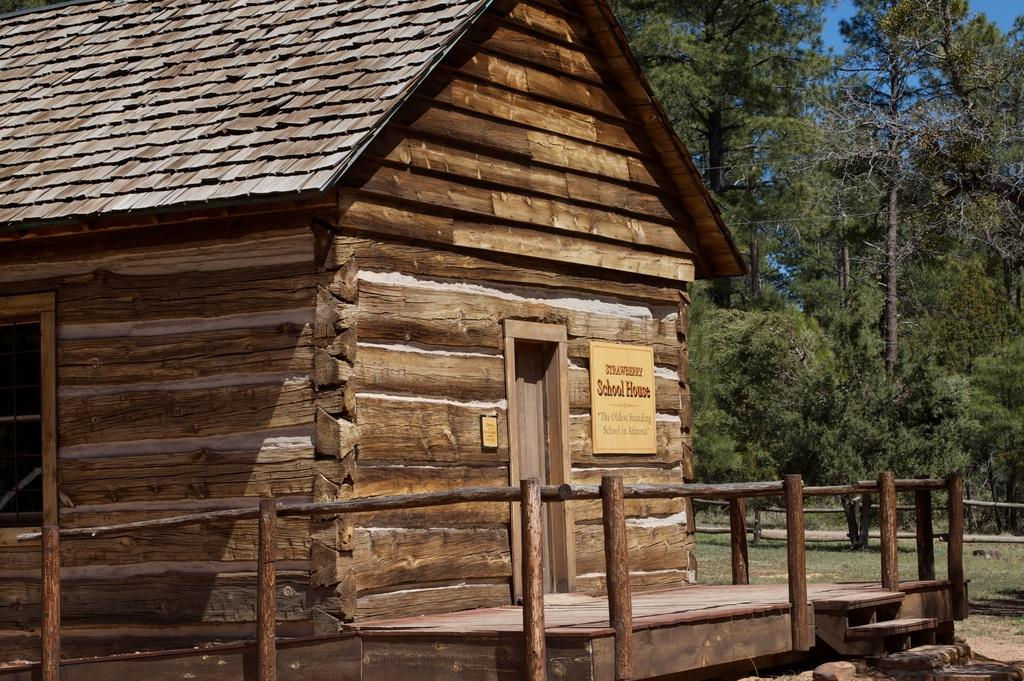What type of house is shown in the image? There is a wooden house in the image. What feature is present in front of the house? There is a wooden railing in front of the house. What can be seen in the background of the image? There are trees and the sky visible in the background of the image. What type of oatmeal is being served on the porch of the house in the image? There is no oatmeal present in the image, nor is there any indication of food being served. 